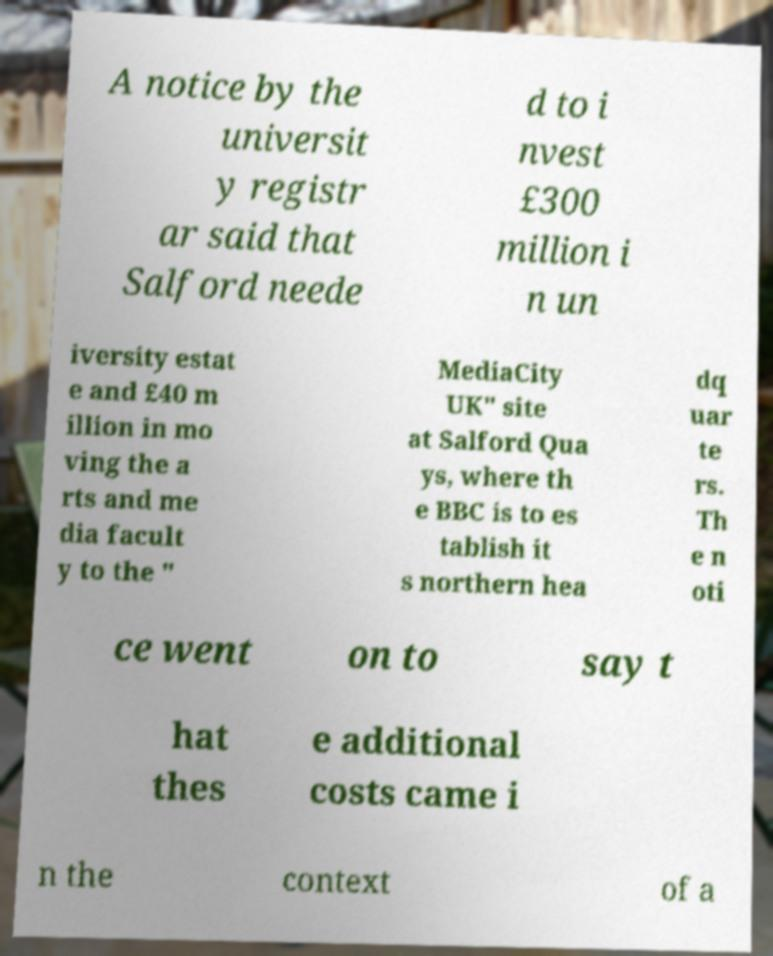Please identify and transcribe the text found in this image. A notice by the universit y registr ar said that Salford neede d to i nvest £300 million i n un iversity estat e and £40 m illion in mo ving the a rts and me dia facult y to the " MediaCity UK" site at Salford Qua ys, where th e BBC is to es tablish it s northern hea dq uar te rs. Th e n oti ce went on to say t hat thes e additional costs came i n the context of a 